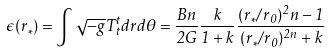<formula> <loc_0><loc_0><loc_500><loc_500>\epsilon ( r _ { * } ) = \int \sqrt { - g } T ^ { t } _ { t } d r d \theta = \frac { B n } { 2 G } \frac { k } { 1 + k } \frac { ( r _ { * } / r _ { 0 } ) ^ { 2 } n - 1 } { ( r _ { * } / r _ { 0 } ) ^ { 2 n } + k }</formula> 